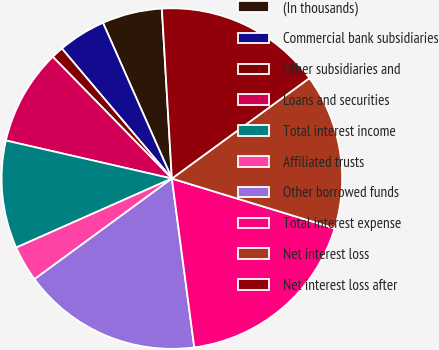<chart> <loc_0><loc_0><loc_500><loc_500><pie_chart><fcel>(In thousands)<fcel>Commercial bank subsidiaries<fcel>Other subsidiaries and<fcel>Loans and securities<fcel>Total interest income<fcel>Affiliated trusts<fcel>Other borrowed funds<fcel>Total interest expense<fcel>Net interest loss<fcel>Net interest loss after<nl><fcel>5.69%<fcel>4.55%<fcel>1.15%<fcel>9.09%<fcel>10.23%<fcel>3.42%<fcel>17.04%<fcel>18.17%<fcel>14.77%<fcel>15.9%<nl></chart> 